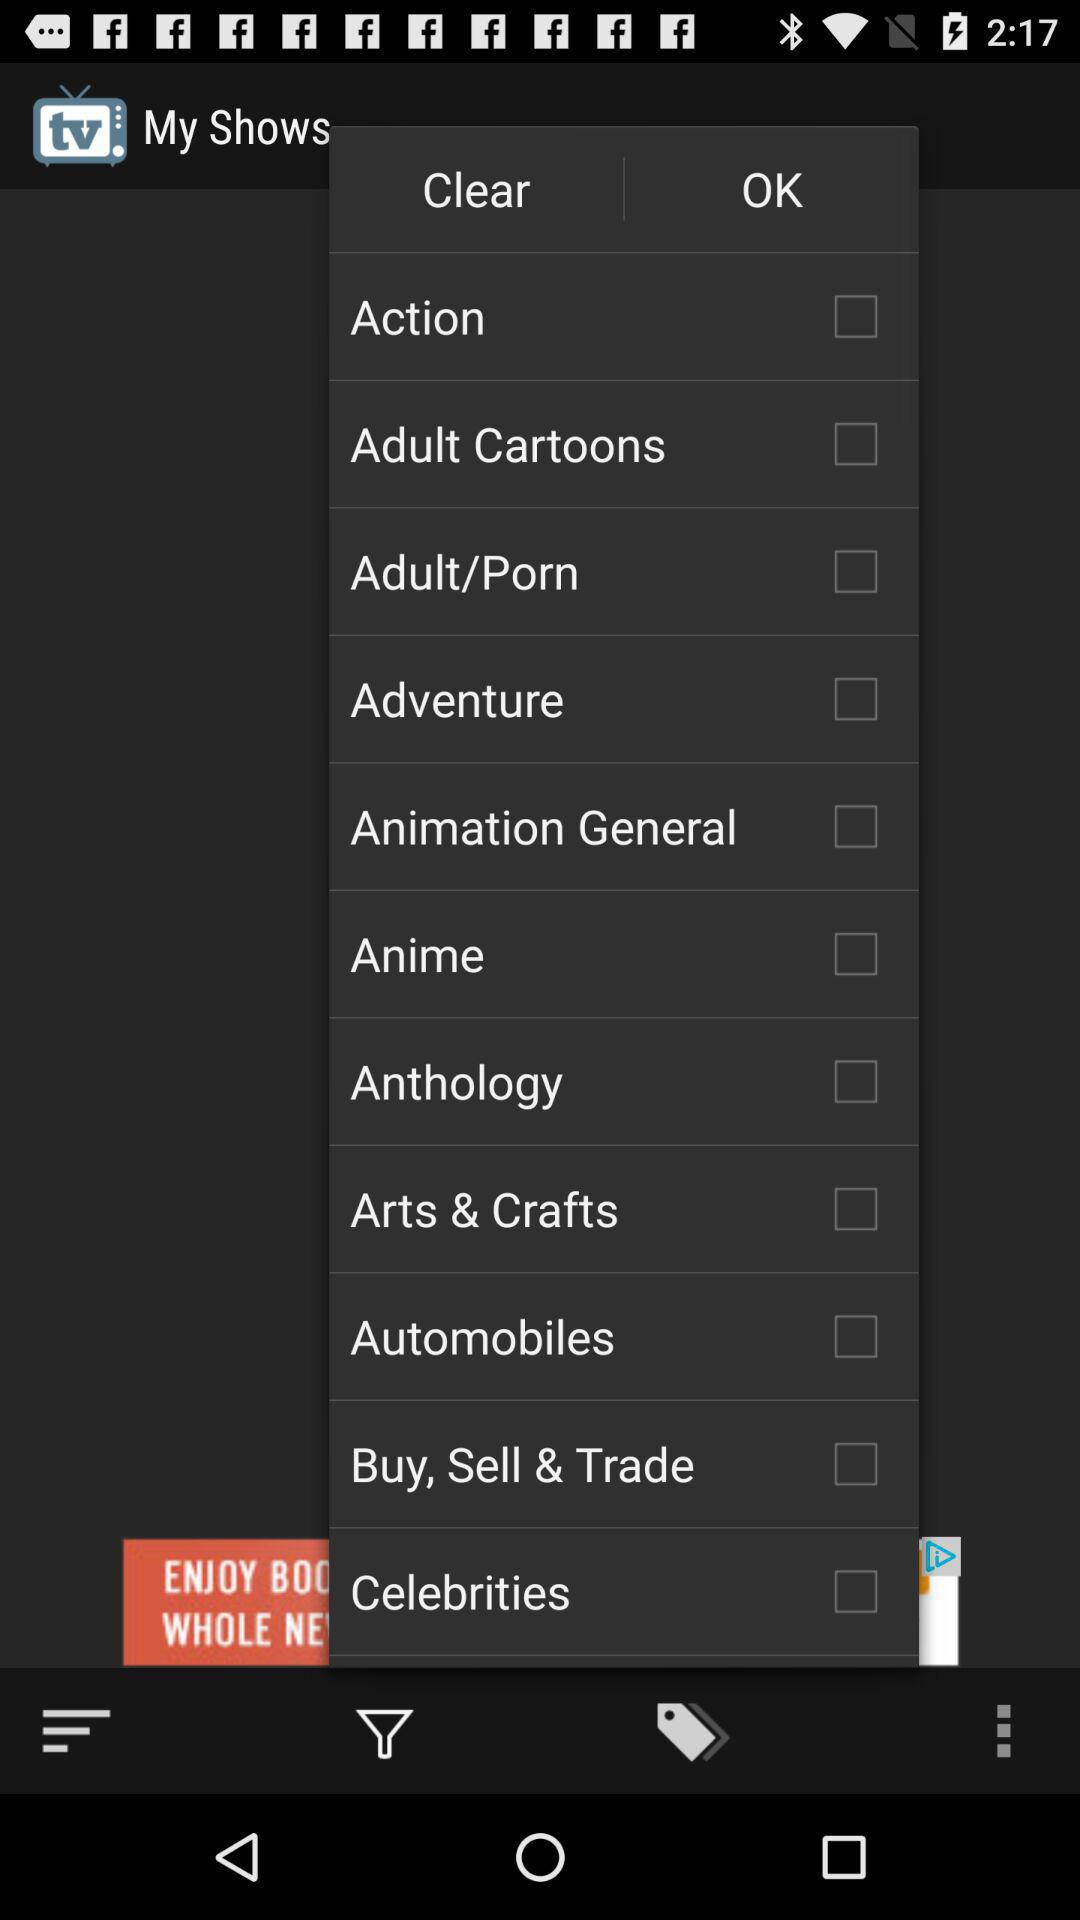What are the different types of genre? The different types of genres are "Action", "Adult Cartoons", "Adult/Porn", "Adventure", "Animation General", "Anime", "Anthology", "Arts & Crafts", "Automobiles", "Buy, Sell & Trade" and "Celebrities". 